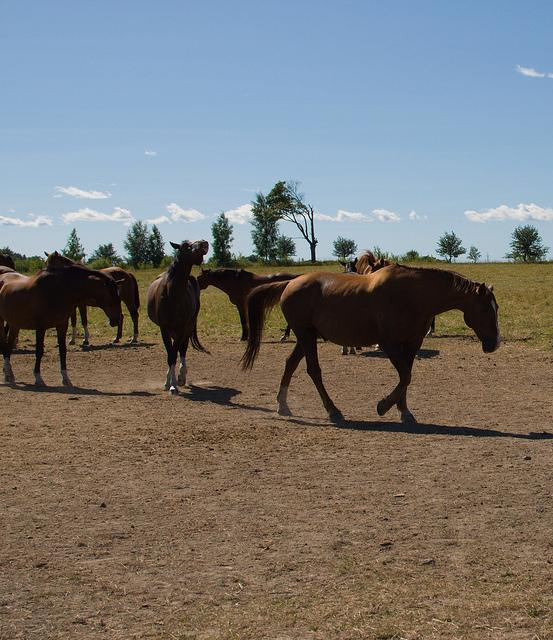This slowly moving horse is doing what? Please explain your reasoning. trotting. The horse is running. 